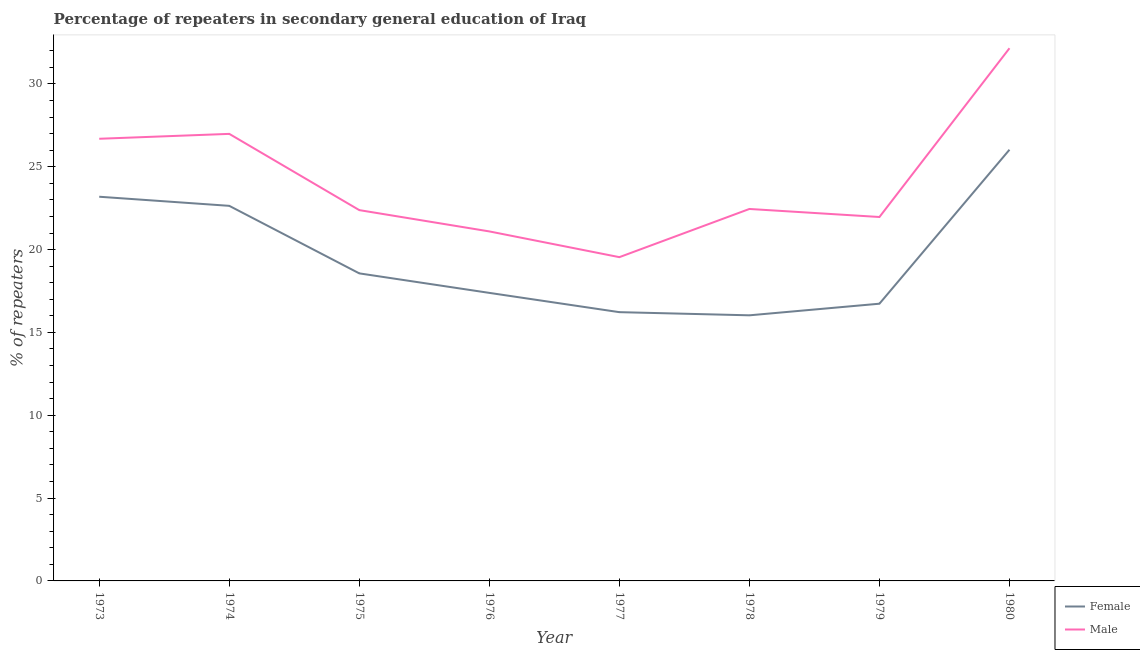What is the percentage of female repeaters in 1974?
Your response must be concise. 22.64. Across all years, what is the maximum percentage of male repeaters?
Provide a short and direct response. 32.15. Across all years, what is the minimum percentage of male repeaters?
Your answer should be very brief. 19.54. In which year was the percentage of male repeaters maximum?
Offer a terse response. 1980. In which year was the percentage of female repeaters minimum?
Your response must be concise. 1978. What is the total percentage of female repeaters in the graph?
Your response must be concise. 156.79. What is the difference between the percentage of female repeaters in 1975 and that in 1979?
Make the answer very short. 1.83. What is the difference between the percentage of female repeaters in 1978 and the percentage of male repeaters in 1973?
Offer a very short reply. -10.66. What is the average percentage of female repeaters per year?
Give a very brief answer. 19.6. In the year 1980, what is the difference between the percentage of male repeaters and percentage of female repeaters?
Make the answer very short. 6.13. In how many years, is the percentage of female repeaters greater than 17 %?
Provide a succinct answer. 5. What is the ratio of the percentage of male repeaters in 1974 to that in 1977?
Your answer should be compact. 1.38. Is the percentage of female repeaters in 1977 less than that in 1978?
Make the answer very short. No. Is the difference between the percentage of male repeaters in 1977 and 1980 greater than the difference between the percentage of female repeaters in 1977 and 1980?
Ensure brevity in your answer.  No. What is the difference between the highest and the second highest percentage of female repeaters?
Keep it short and to the point. 2.84. What is the difference between the highest and the lowest percentage of male repeaters?
Offer a very short reply. 12.61. In how many years, is the percentage of male repeaters greater than the average percentage of male repeaters taken over all years?
Ensure brevity in your answer.  3. Does the percentage of female repeaters monotonically increase over the years?
Keep it short and to the point. No. How many years are there in the graph?
Provide a short and direct response. 8. What is the difference between two consecutive major ticks on the Y-axis?
Your response must be concise. 5. Are the values on the major ticks of Y-axis written in scientific E-notation?
Keep it short and to the point. No. Does the graph contain any zero values?
Your response must be concise. No. Where does the legend appear in the graph?
Your answer should be compact. Bottom right. How many legend labels are there?
Give a very brief answer. 2. What is the title of the graph?
Make the answer very short. Percentage of repeaters in secondary general education of Iraq. Does "Non-residents" appear as one of the legend labels in the graph?
Your response must be concise. No. What is the label or title of the X-axis?
Your answer should be compact. Year. What is the label or title of the Y-axis?
Offer a terse response. % of repeaters. What is the % of repeaters in Female in 1973?
Your answer should be very brief. 23.19. What is the % of repeaters in Male in 1973?
Make the answer very short. 26.69. What is the % of repeaters in Female in 1974?
Your answer should be compact. 22.64. What is the % of repeaters of Male in 1974?
Provide a succinct answer. 26.98. What is the % of repeaters in Female in 1975?
Your answer should be compact. 18.56. What is the % of repeaters of Male in 1975?
Ensure brevity in your answer.  22.38. What is the % of repeaters in Female in 1976?
Your answer should be very brief. 17.39. What is the % of repeaters in Male in 1976?
Give a very brief answer. 21.1. What is the % of repeaters of Female in 1977?
Give a very brief answer. 16.22. What is the % of repeaters in Male in 1977?
Offer a terse response. 19.54. What is the % of repeaters in Female in 1978?
Offer a terse response. 16.03. What is the % of repeaters in Male in 1978?
Ensure brevity in your answer.  22.45. What is the % of repeaters of Female in 1979?
Provide a short and direct response. 16.73. What is the % of repeaters of Male in 1979?
Make the answer very short. 21.97. What is the % of repeaters of Female in 1980?
Offer a very short reply. 26.03. What is the % of repeaters of Male in 1980?
Your answer should be very brief. 32.15. Across all years, what is the maximum % of repeaters of Female?
Make the answer very short. 26.03. Across all years, what is the maximum % of repeaters in Male?
Your response must be concise. 32.15. Across all years, what is the minimum % of repeaters of Female?
Offer a very short reply. 16.03. Across all years, what is the minimum % of repeaters in Male?
Provide a short and direct response. 19.54. What is the total % of repeaters in Female in the graph?
Give a very brief answer. 156.79. What is the total % of repeaters of Male in the graph?
Your answer should be very brief. 193.26. What is the difference between the % of repeaters in Female in 1973 and that in 1974?
Your answer should be compact. 0.55. What is the difference between the % of repeaters in Male in 1973 and that in 1974?
Your answer should be very brief. -0.3. What is the difference between the % of repeaters in Female in 1973 and that in 1975?
Your answer should be very brief. 4.63. What is the difference between the % of repeaters in Male in 1973 and that in 1975?
Give a very brief answer. 4.31. What is the difference between the % of repeaters of Female in 1973 and that in 1976?
Your answer should be very brief. 5.8. What is the difference between the % of repeaters in Male in 1973 and that in 1976?
Provide a short and direct response. 5.59. What is the difference between the % of repeaters of Female in 1973 and that in 1977?
Make the answer very short. 6.97. What is the difference between the % of repeaters of Male in 1973 and that in 1977?
Offer a terse response. 7.15. What is the difference between the % of repeaters in Female in 1973 and that in 1978?
Your answer should be compact. 7.16. What is the difference between the % of repeaters of Male in 1973 and that in 1978?
Keep it short and to the point. 4.24. What is the difference between the % of repeaters of Female in 1973 and that in 1979?
Your answer should be very brief. 6.46. What is the difference between the % of repeaters in Male in 1973 and that in 1979?
Offer a terse response. 4.72. What is the difference between the % of repeaters in Female in 1973 and that in 1980?
Provide a short and direct response. -2.84. What is the difference between the % of repeaters in Male in 1973 and that in 1980?
Your response must be concise. -5.46. What is the difference between the % of repeaters in Female in 1974 and that in 1975?
Your answer should be very brief. 4.08. What is the difference between the % of repeaters of Male in 1974 and that in 1975?
Your answer should be very brief. 4.6. What is the difference between the % of repeaters of Female in 1974 and that in 1976?
Offer a terse response. 5.25. What is the difference between the % of repeaters of Male in 1974 and that in 1976?
Make the answer very short. 5.89. What is the difference between the % of repeaters of Female in 1974 and that in 1977?
Offer a very short reply. 6.42. What is the difference between the % of repeaters of Male in 1974 and that in 1977?
Offer a very short reply. 7.44. What is the difference between the % of repeaters in Female in 1974 and that in 1978?
Offer a terse response. 6.61. What is the difference between the % of repeaters in Male in 1974 and that in 1978?
Give a very brief answer. 4.53. What is the difference between the % of repeaters in Female in 1974 and that in 1979?
Give a very brief answer. 5.91. What is the difference between the % of repeaters in Male in 1974 and that in 1979?
Offer a very short reply. 5.02. What is the difference between the % of repeaters in Female in 1974 and that in 1980?
Your answer should be very brief. -3.39. What is the difference between the % of repeaters of Male in 1974 and that in 1980?
Provide a short and direct response. -5.17. What is the difference between the % of repeaters of Female in 1975 and that in 1976?
Give a very brief answer. 1.18. What is the difference between the % of repeaters of Male in 1975 and that in 1976?
Provide a short and direct response. 1.29. What is the difference between the % of repeaters in Female in 1975 and that in 1977?
Keep it short and to the point. 2.34. What is the difference between the % of repeaters in Male in 1975 and that in 1977?
Make the answer very short. 2.84. What is the difference between the % of repeaters in Female in 1975 and that in 1978?
Your response must be concise. 2.53. What is the difference between the % of repeaters of Male in 1975 and that in 1978?
Offer a terse response. -0.07. What is the difference between the % of repeaters in Female in 1975 and that in 1979?
Your answer should be compact. 1.83. What is the difference between the % of repeaters in Male in 1975 and that in 1979?
Your answer should be compact. 0.42. What is the difference between the % of repeaters of Female in 1975 and that in 1980?
Give a very brief answer. -7.46. What is the difference between the % of repeaters in Male in 1975 and that in 1980?
Give a very brief answer. -9.77. What is the difference between the % of repeaters in Female in 1976 and that in 1977?
Your answer should be compact. 1.16. What is the difference between the % of repeaters in Male in 1976 and that in 1977?
Make the answer very short. 1.55. What is the difference between the % of repeaters of Female in 1976 and that in 1978?
Keep it short and to the point. 1.35. What is the difference between the % of repeaters of Male in 1976 and that in 1978?
Offer a very short reply. -1.35. What is the difference between the % of repeaters of Female in 1976 and that in 1979?
Offer a terse response. 0.65. What is the difference between the % of repeaters in Male in 1976 and that in 1979?
Your response must be concise. -0.87. What is the difference between the % of repeaters of Female in 1976 and that in 1980?
Ensure brevity in your answer.  -8.64. What is the difference between the % of repeaters of Male in 1976 and that in 1980?
Your answer should be very brief. -11.06. What is the difference between the % of repeaters of Female in 1977 and that in 1978?
Give a very brief answer. 0.19. What is the difference between the % of repeaters of Male in 1977 and that in 1978?
Provide a succinct answer. -2.91. What is the difference between the % of repeaters in Female in 1977 and that in 1979?
Ensure brevity in your answer.  -0.51. What is the difference between the % of repeaters of Male in 1977 and that in 1979?
Your response must be concise. -2.42. What is the difference between the % of repeaters of Female in 1977 and that in 1980?
Give a very brief answer. -9.81. What is the difference between the % of repeaters of Male in 1977 and that in 1980?
Give a very brief answer. -12.61. What is the difference between the % of repeaters of Female in 1978 and that in 1979?
Provide a succinct answer. -0.7. What is the difference between the % of repeaters in Male in 1978 and that in 1979?
Offer a very short reply. 0.48. What is the difference between the % of repeaters in Female in 1978 and that in 1980?
Keep it short and to the point. -10. What is the difference between the % of repeaters of Male in 1978 and that in 1980?
Offer a very short reply. -9.7. What is the difference between the % of repeaters of Female in 1979 and that in 1980?
Your answer should be very brief. -9.29. What is the difference between the % of repeaters of Male in 1979 and that in 1980?
Your answer should be very brief. -10.19. What is the difference between the % of repeaters in Female in 1973 and the % of repeaters in Male in 1974?
Give a very brief answer. -3.79. What is the difference between the % of repeaters of Female in 1973 and the % of repeaters of Male in 1975?
Provide a succinct answer. 0.81. What is the difference between the % of repeaters of Female in 1973 and the % of repeaters of Male in 1976?
Your response must be concise. 2.09. What is the difference between the % of repeaters of Female in 1973 and the % of repeaters of Male in 1977?
Provide a short and direct response. 3.65. What is the difference between the % of repeaters in Female in 1973 and the % of repeaters in Male in 1978?
Provide a succinct answer. 0.74. What is the difference between the % of repeaters in Female in 1973 and the % of repeaters in Male in 1979?
Provide a succinct answer. 1.22. What is the difference between the % of repeaters of Female in 1973 and the % of repeaters of Male in 1980?
Make the answer very short. -8.96. What is the difference between the % of repeaters in Female in 1974 and the % of repeaters in Male in 1975?
Give a very brief answer. 0.26. What is the difference between the % of repeaters of Female in 1974 and the % of repeaters of Male in 1976?
Your answer should be very brief. 1.54. What is the difference between the % of repeaters of Female in 1974 and the % of repeaters of Male in 1977?
Your answer should be very brief. 3.1. What is the difference between the % of repeaters of Female in 1974 and the % of repeaters of Male in 1978?
Keep it short and to the point. 0.19. What is the difference between the % of repeaters of Female in 1974 and the % of repeaters of Male in 1979?
Offer a very short reply. 0.67. What is the difference between the % of repeaters of Female in 1974 and the % of repeaters of Male in 1980?
Keep it short and to the point. -9.51. What is the difference between the % of repeaters of Female in 1975 and the % of repeaters of Male in 1976?
Offer a terse response. -2.53. What is the difference between the % of repeaters in Female in 1975 and the % of repeaters in Male in 1977?
Give a very brief answer. -0.98. What is the difference between the % of repeaters of Female in 1975 and the % of repeaters of Male in 1978?
Provide a short and direct response. -3.89. What is the difference between the % of repeaters of Female in 1975 and the % of repeaters of Male in 1979?
Your answer should be very brief. -3.4. What is the difference between the % of repeaters in Female in 1975 and the % of repeaters in Male in 1980?
Give a very brief answer. -13.59. What is the difference between the % of repeaters in Female in 1976 and the % of repeaters in Male in 1977?
Offer a terse response. -2.16. What is the difference between the % of repeaters of Female in 1976 and the % of repeaters of Male in 1978?
Make the answer very short. -5.06. What is the difference between the % of repeaters of Female in 1976 and the % of repeaters of Male in 1979?
Provide a short and direct response. -4.58. What is the difference between the % of repeaters of Female in 1976 and the % of repeaters of Male in 1980?
Give a very brief answer. -14.77. What is the difference between the % of repeaters of Female in 1977 and the % of repeaters of Male in 1978?
Your answer should be very brief. -6.23. What is the difference between the % of repeaters in Female in 1977 and the % of repeaters in Male in 1979?
Offer a very short reply. -5.74. What is the difference between the % of repeaters in Female in 1977 and the % of repeaters in Male in 1980?
Keep it short and to the point. -15.93. What is the difference between the % of repeaters of Female in 1978 and the % of repeaters of Male in 1979?
Give a very brief answer. -5.93. What is the difference between the % of repeaters in Female in 1978 and the % of repeaters in Male in 1980?
Make the answer very short. -16.12. What is the difference between the % of repeaters of Female in 1979 and the % of repeaters of Male in 1980?
Give a very brief answer. -15.42. What is the average % of repeaters of Female per year?
Your answer should be very brief. 19.6. What is the average % of repeaters of Male per year?
Your answer should be compact. 24.16. In the year 1973, what is the difference between the % of repeaters of Female and % of repeaters of Male?
Make the answer very short. -3.5. In the year 1974, what is the difference between the % of repeaters in Female and % of repeaters in Male?
Make the answer very short. -4.34. In the year 1975, what is the difference between the % of repeaters in Female and % of repeaters in Male?
Your response must be concise. -3.82. In the year 1976, what is the difference between the % of repeaters in Female and % of repeaters in Male?
Your answer should be very brief. -3.71. In the year 1977, what is the difference between the % of repeaters in Female and % of repeaters in Male?
Provide a short and direct response. -3.32. In the year 1978, what is the difference between the % of repeaters of Female and % of repeaters of Male?
Offer a very short reply. -6.42. In the year 1979, what is the difference between the % of repeaters in Female and % of repeaters in Male?
Offer a very short reply. -5.23. In the year 1980, what is the difference between the % of repeaters in Female and % of repeaters in Male?
Provide a short and direct response. -6.13. What is the ratio of the % of repeaters in Female in 1973 to that in 1974?
Give a very brief answer. 1.02. What is the ratio of the % of repeaters in Female in 1973 to that in 1975?
Give a very brief answer. 1.25. What is the ratio of the % of repeaters in Male in 1973 to that in 1975?
Give a very brief answer. 1.19. What is the ratio of the % of repeaters in Female in 1973 to that in 1976?
Offer a terse response. 1.33. What is the ratio of the % of repeaters in Male in 1973 to that in 1976?
Offer a very short reply. 1.27. What is the ratio of the % of repeaters of Female in 1973 to that in 1977?
Ensure brevity in your answer.  1.43. What is the ratio of the % of repeaters in Male in 1973 to that in 1977?
Offer a very short reply. 1.37. What is the ratio of the % of repeaters in Female in 1973 to that in 1978?
Your answer should be very brief. 1.45. What is the ratio of the % of repeaters in Male in 1973 to that in 1978?
Ensure brevity in your answer.  1.19. What is the ratio of the % of repeaters of Female in 1973 to that in 1979?
Give a very brief answer. 1.39. What is the ratio of the % of repeaters of Male in 1973 to that in 1979?
Make the answer very short. 1.22. What is the ratio of the % of repeaters in Female in 1973 to that in 1980?
Your answer should be compact. 0.89. What is the ratio of the % of repeaters of Male in 1973 to that in 1980?
Give a very brief answer. 0.83. What is the ratio of the % of repeaters in Female in 1974 to that in 1975?
Ensure brevity in your answer.  1.22. What is the ratio of the % of repeaters in Male in 1974 to that in 1975?
Your response must be concise. 1.21. What is the ratio of the % of repeaters in Female in 1974 to that in 1976?
Your answer should be compact. 1.3. What is the ratio of the % of repeaters of Male in 1974 to that in 1976?
Provide a short and direct response. 1.28. What is the ratio of the % of repeaters of Female in 1974 to that in 1977?
Your answer should be very brief. 1.4. What is the ratio of the % of repeaters in Male in 1974 to that in 1977?
Ensure brevity in your answer.  1.38. What is the ratio of the % of repeaters in Female in 1974 to that in 1978?
Offer a very short reply. 1.41. What is the ratio of the % of repeaters in Male in 1974 to that in 1978?
Keep it short and to the point. 1.2. What is the ratio of the % of repeaters of Female in 1974 to that in 1979?
Your response must be concise. 1.35. What is the ratio of the % of repeaters in Male in 1974 to that in 1979?
Make the answer very short. 1.23. What is the ratio of the % of repeaters of Female in 1974 to that in 1980?
Your answer should be compact. 0.87. What is the ratio of the % of repeaters in Male in 1974 to that in 1980?
Provide a short and direct response. 0.84. What is the ratio of the % of repeaters in Female in 1975 to that in 1976?
Your answer should be very brief. 1.07. What is the ratio of the % of repeaters of Male in 1975 to that in 1976?
Offer a terse response. 1.06. What is the ratio of the % of repeaters of Female in 1975 to that in 1977?
Give a very brief answer. 1.14. What is the ratio of the % of repeaters of Male in 1975 to that in 1977?
Your response must be concise. 1.15. What is the ratio of the % of repeaters in Female in 1975 to that in 1978?
Offer a terse response. 1.16. What is the ratio of the % of repeaters in Female in 1975 to that in 1979?
Offer a terse response. 1.11. What is the ratio of the % of repeaters in Male in 1975 to that in 1979?
Your response must be concise. 1.02. What is the ratio of the % of repeaters of Female in 1975 to that in 1980?
Offer a terse response. 0.71. What is the ratio of the % of repeaters in Male in 1975 to that in 1980?
Make the answer very short. 0.7. What is the ratio of the % of repeaters in Female in 1976 to that in 1977?
Make the answer very short. 1.07. What is the ratio of the % of repeaters of Male in 1976 to that in 1977?
Provide a succinct answer. 1.08. What is the ratio of the % of repeaters in Female in 1976 to that in 1978?
Give a very brief answer. 1.08. What is the ratio of the % of repeaters in Male in 1976 to that in 1978?
Offer a terse response. 0.94. What is the ratio of the % of repeaters of Female in 1976 to that in 1979?
Your answer should be very brief. 1.04. What is the ratio of the % of repeaters of Male in 1976 to that in 1979?
Provide a succinct answer. 0.96. What is the ratio of the % of repeaters of Female in 1976 to that in 1980?
Ensure brevity in your answer.  0.67. What is the ratio of the % of repeaters of Male in 1976 to that in 1980?
Ensure brevity in your answer.  0.66. What is the ratio of the % of repeaters in Female in 1977 to that in 1978?
Ensure brevity in your answer.  1.01. What is the ratio of the % of repeaters in Male in 1977 to that in 1978?
Your answer should be very brief. 0.87. What is the ratio of the % of repeaters of Female in 1977 to that in 1979?
Offer a very short reply. 0.97. What is the ratio of the % of repeaters in Male in 1977 to that in 1979?
Your response must be concise. 0.89. What is the ratio of the % of repeaters of Female in 1977 to that in 1980?
Make the answer very short. 0.62. What is the ratio of the % of repeaters of Male in 1977 to that in 1980?
Your answer should be very brief. 0.61. What is the ratio of the % of repeaters in Female in 1978 to that in 1979?
Offer a very short reply. 0.96. What is the ratio of the % of repeaters in Male in 1978 to that in 1979?
Offer a terse response. 1.02. What is the ratio of the % of repeaters in Female in 1978 to that in 1980?
Your answer should be very brief. 0.62. What is the ratio of the % of repeaters in Male in 1978 to that in 1980?
Your answer should be very brief. 0.7. What is the ratio of the % of repeaters in Female in 1979 to that in 1980?
Ensure brevity in your answer.  0.64. What is the ratio of the % of repeaters of Male in 1979 to that in 1980?
Make the answer very short. 0.68. What is the difference between the highest and the second highest % of repeaters of Female?
Keep it short and to the point. 2.84. What is the difference between the highest and the second highest % of repeaters of Male?
Make the answer very short. 5.17. What is the difference between the highest and the lowest % of repeaters in Female?
Keep it short and to the point. 10. What is the difference between the highest and the lowest % of repeaters in Male?
Provide a short and direct response. 12.61. 